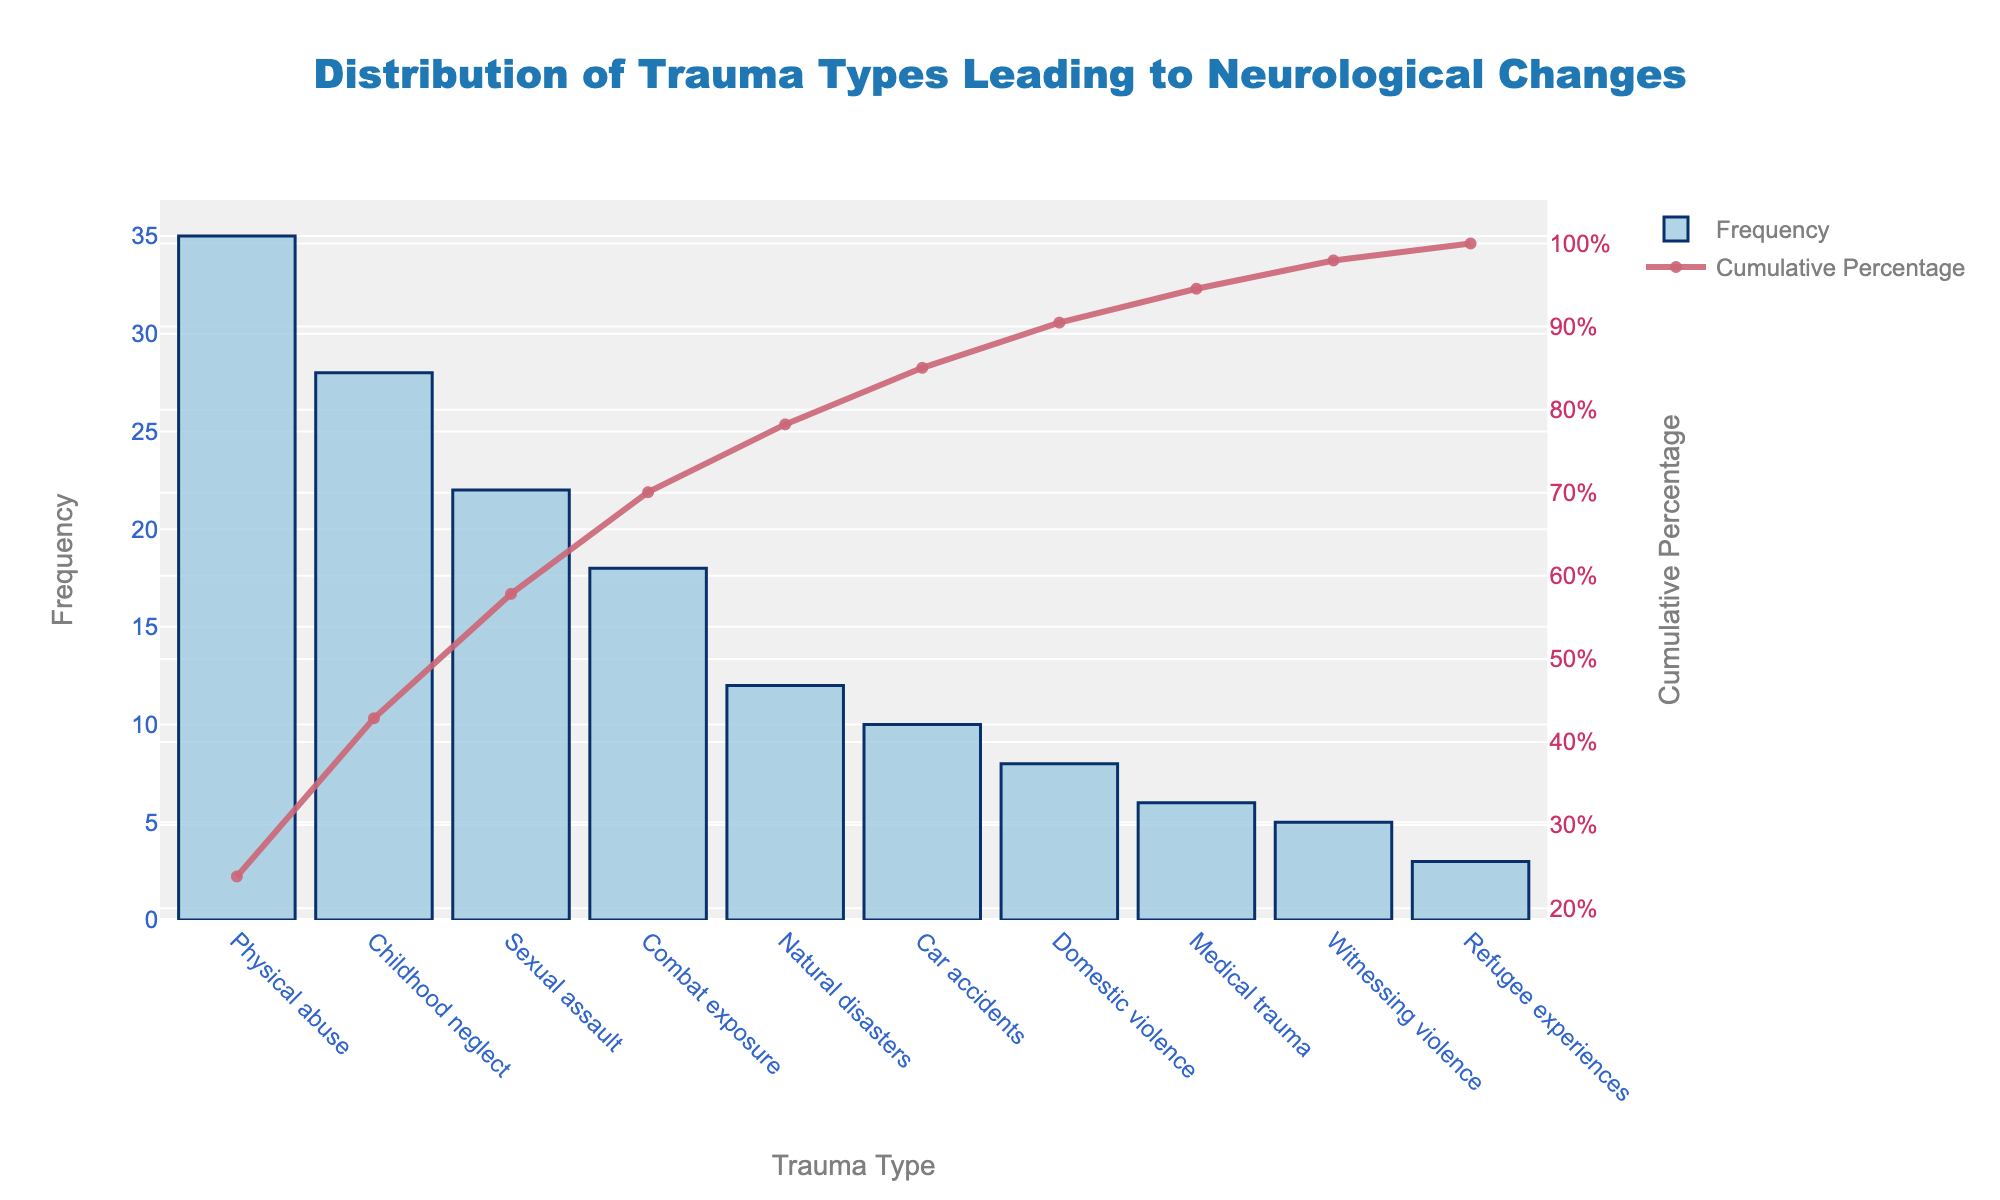What is the most common type of trauma leading to neurological changes? The most common type of trauma leading to neurological changes is identified by looking at the highest bar in the chart, which corresponds to physical abuse.
Answer: Physical abuse What percentage of neurological changes are caused by the three most common trauma types? To find the percentage, sum the frequencies of the three most common types (Physical abuse: 35, Childhood neglect: 28, Sexual assault: 22), and divide by the total frequency, then multiply by 100. Total frequency = 35 + 28 + 22 = 85. Overall frequency = 147. Percentage = (85 / 147) * 100 = 57.82%
Answer: 57.82% Which trauma type has the lowest frequency of leading to neurological changes? The trauma type with the lowest frequency is the one with the smallest bar on the chart, which corresponds to refugee experiences.
Answer: Refugee experiences How does the frequency of domestic violence compare to that of medical trauma? Compare the heights of the bars for domestic violence (8) and medical trauma (6). Domestic violence has a higher frequency than medical trauma.
Answer: Domestic violence has a higher frequency At what point does the cumulative percentage exceed 75%? To determine this, find the trauma type where the cumulative percentage curve crosses 75%. According to the data, this happens between Sexual assault and Combat exposure.
Answer: Between Sexual assault and Combat exposure How many trauma types account for roughly half of the cases leading to neurological changes? Determine the cumulative frequency percentage by adding the frequencies until the cumulative sum is approximately 50%. Physical abuse (35), Childhood neglect (28), and Sexual assault (22) approximate to 85, which is about 57.82% of the total (85/147 * 100 = 57.82%). The requirement is met by the top three trauma types.
Answer: 3 Which trauma type accounts for the steepest increase in cumulative percentage? The steepest increase in cumulative percentage is associated with the trauma type that causes the largest jump between adjacent cumulative percentages. This is the first trauma type, Physical abuse, as adding it greatly increases the cumulative percentage initially.
Answer: Physical abuse What is the approximate cumulative percentage after accounting for both car accidents and domestic violence? Sum the frequencies for car accidents (10) and domestic violence (8), then find the cumulative percentage (Car accidents + Domestic violence = 10 + 8 = 18; Cumulative percentage after adding previous trauma types up to car accidents = 85 + 18 = 103, and cumulative percentage = (103 / 147) * 100 ≈ 70.07%)
Answer: 70.07% Which trauma types contribute equally to the cumulative percentage? Look for trauma types where the bars are of equal height, leading to equal contribution in frequencies. Here, none have exactly the same frequency, but natural disasters (12) and car accidents (10) are the closest in contribution being consecutive data points on the chart.
Answer: No exact equal contributors, closest are natural disasters and car accidents 